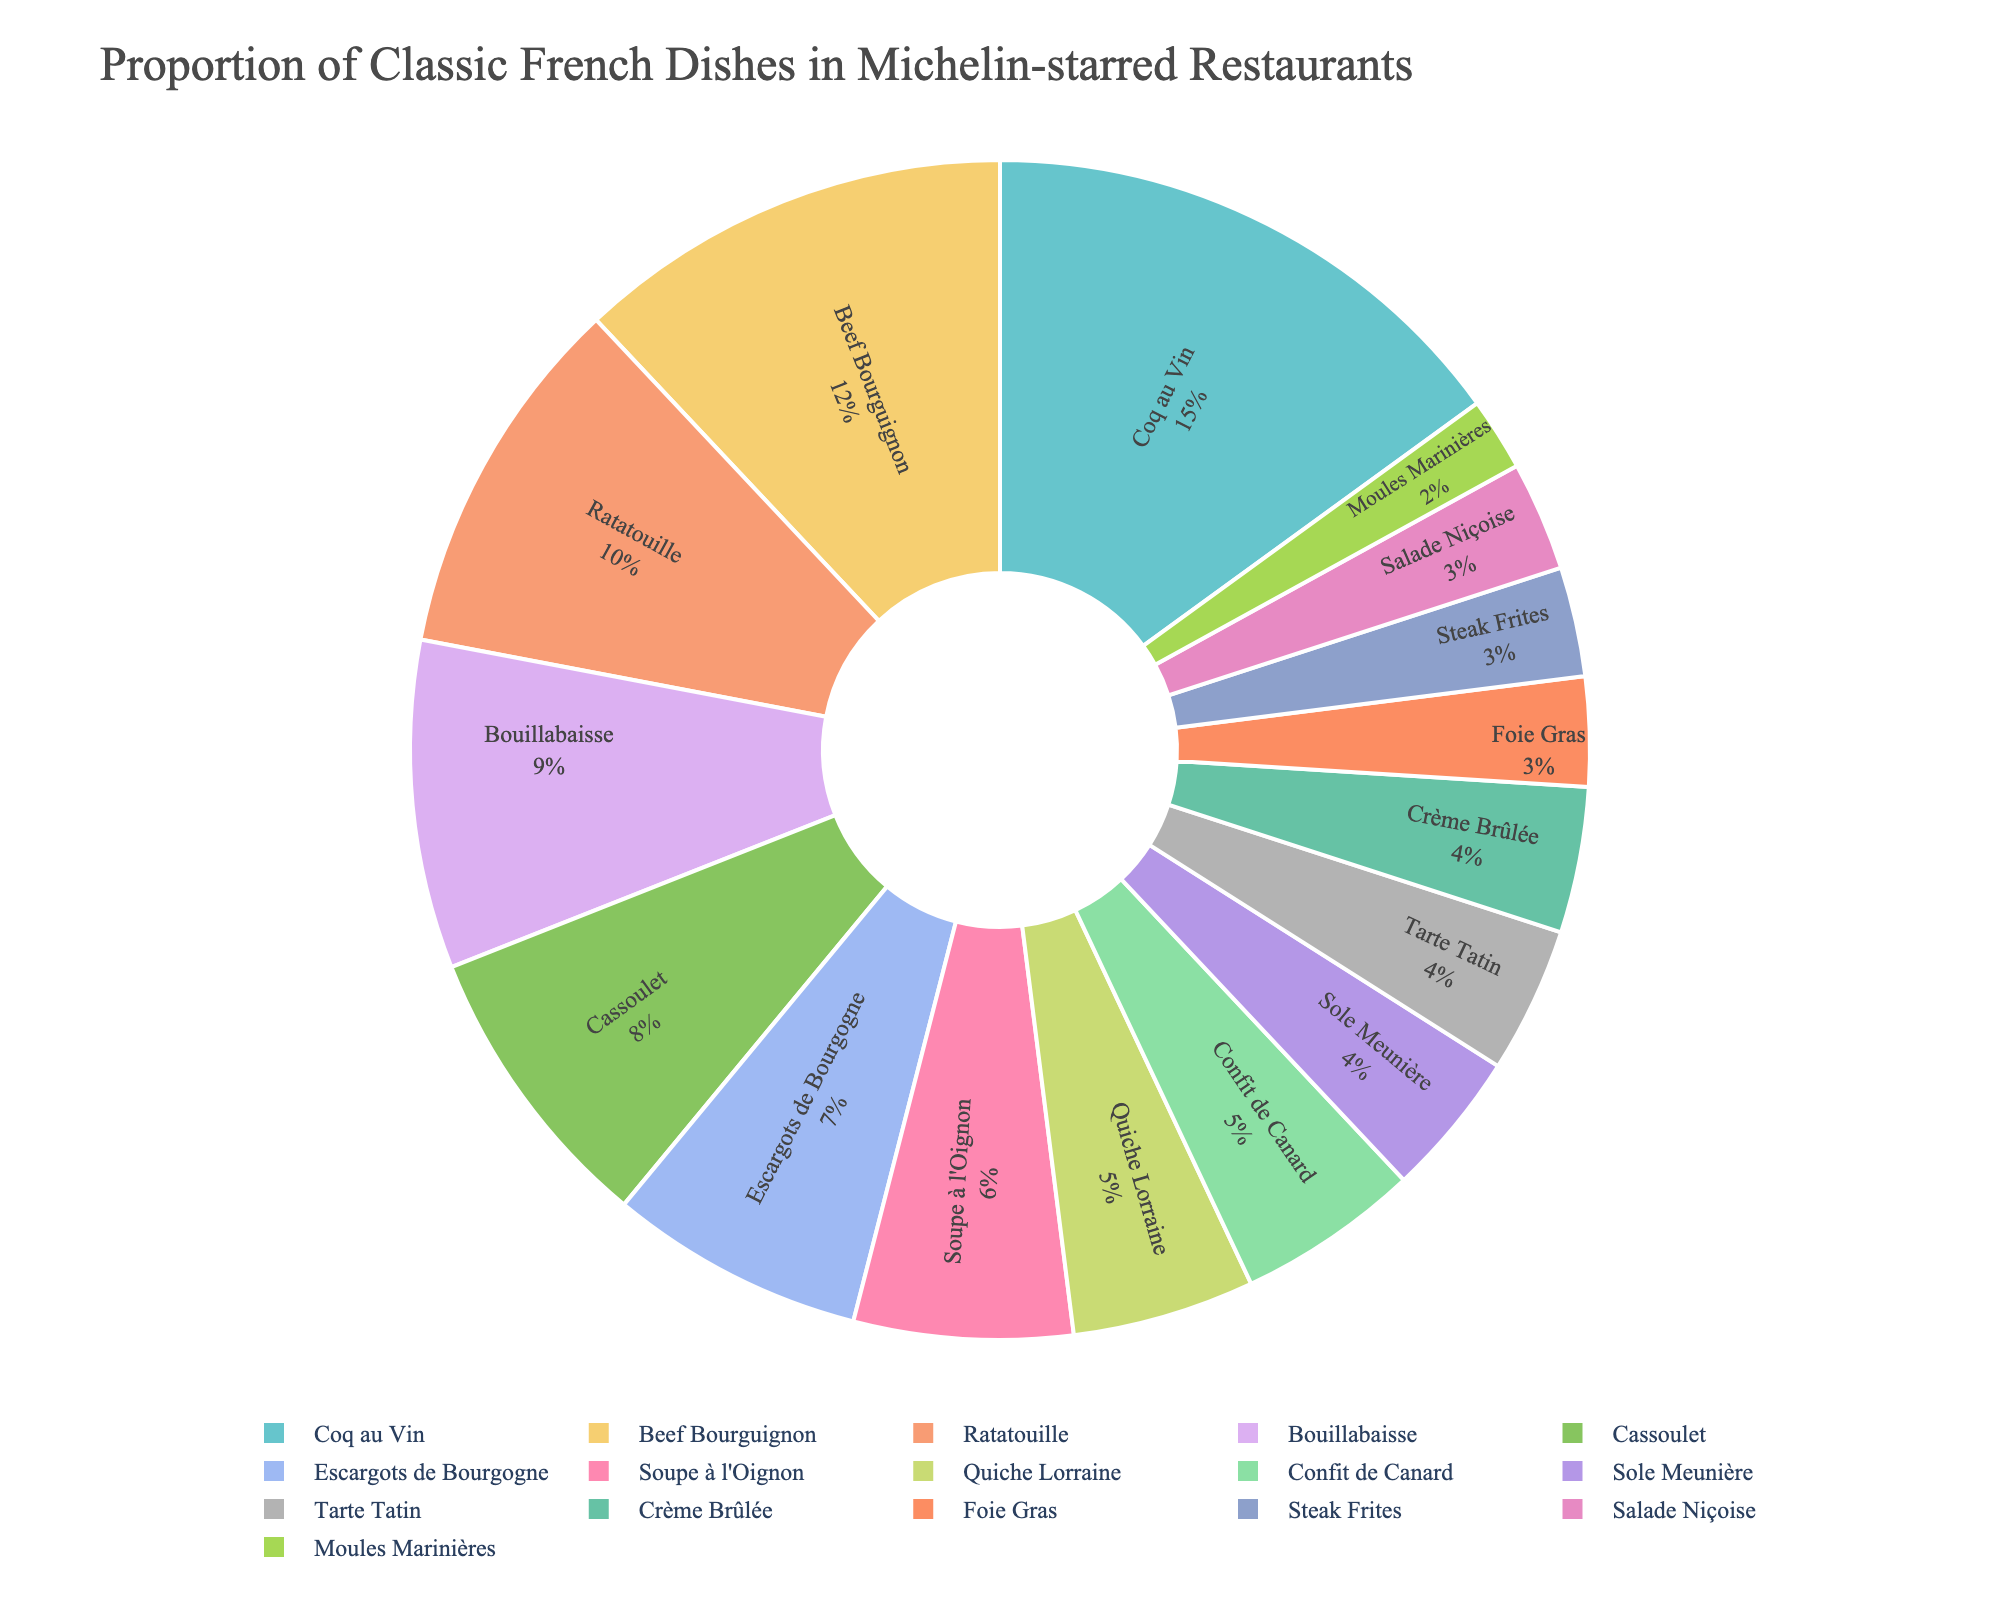Which dish has the highest percentage of representation in Michelin-starred restaurants? Looking at the pie chart, the dish with the largest segment would have the highest percentage. Coq au Vin has the highest representation with 15%.
Answer: Coq au Vin What is the combined percentage of dishes that represent 10% or more? Add the percentages of Coq au Vin (15%), Beef Bourguignon (12%), and Ratatouille (10%), as these are the dishes that represent 10% or more. So, 15 + 12 + 10 = 37%.
Answer: 37% Which dish is more common in Michelin-starred restaurants: Bouillabaisse or Tarte Tatin? Compare the percentages of Bouillabaisse (9%) and Tarte Tatin (4%). Bouillabaisse has a higher percentage than Tarte Tatin.
Answer: Bouillabaisse Which dish has the smallest representation, and what percentage does it hold? Identify the dish with the smallest segment in the pie chart, which is Moules Marinières at 2%.
Answer: Moules Marinières, 2% How does the percentage of Escargots de Bourgogne compare to that of Crème Brûlée? Compare the percentages of Escargots de Bourgogne (7%) and Crème Brûlée (4%). Escargots de Bourgogne has a higher percentage.
Answer: Escargots de Bourgogne What is the average percentage representation of dishes listed in the pie chart? Sum all the percentages and divide by the number of dishes. (15 + 12 + 10 + 9 + 8 + 7 + 6 + 5 + 5 + 4 + 4 + 4 + 3 + 3 + 3 + 2) / 16 = 100 / 16 = 6.25%
Answer: 6.25% Which three dishes combined make up one-third (approximately 33%) of the total proportion? Find the combination of three dishes whose percentages sum up to around 33%. Coq au Vin (15%) + Beef Bourguignon (12%) + Ratatouille (10%) = 37%, or, Beef Bourguignon (12%) + Ratatouille (10%) + Bouillabaisse (9%) + Cassoulet (8%) = 30%. Though not exactly, they are close and since the closest sum is used.
Answer: Coq au Vin, Beef Bourguignon, Ratatouille What color is the segment representing the Ratatouille dish in the pie chart? Look at the pie chart and identify the color associated with the segment labeled Ratatouille.
Answer: Color of the segment (Please refer to the actual chart image for color) How many dishes are represented by 4% each in the pie chart? Count the number of dishes that are labeled with a 4% segment in the pie chart. There are three such dishes: Sole Meunière, Tarte Tatin, and Crème Brûlée.
Answer: Three dishes 